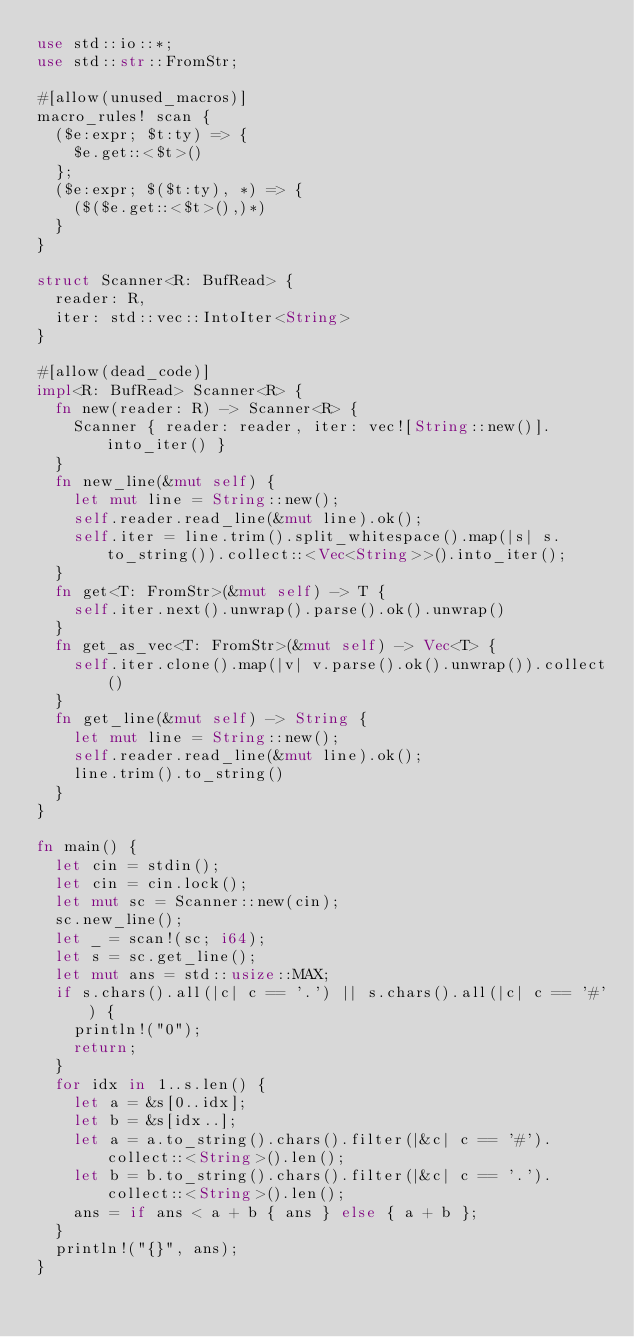Convert code to text. <code><loc_0><loc_0><loc_500><loc_500><_Rust_>use std::io::*;
use std::str::FromStr;

#[allow(unused_macros)]
macro_rules! scan {
  ($e:expr; $t:ty) => {
    $e.get::<$t>()
  };
  ($e:expr; $($t:ty), *) => {
    ($($e.get::<$t>(),)*)
  }
}

struct Scanner<R: BufRead> {
  reader: R,
  iter: std::vec::IntoIter<String>
}

#[allow(dead_code)]
impl<R: BufRead> Scanner<R> {
  fn new(reader: R) -> Scanner<R> {
    Scanner { reader: reader, iter: vec![String::new()].into_iter() }
  }
  fn new_line(&mut self) {
    let mut line = String::new();
    self.reader.read_line(&mut line).ok();
    self.iter = line.trim().split_whitespace().map(|s| s.to_string()).collect::<Vec<String>>().into_iter();
  }
  fn get<T: FromStr>(&mut self) -> T {
    self.iter.next().unwrap().parse().ok().unwrap()
  }
  fn get_as_vec<T: FromStr>(&mut self) -> Vec<T> {
    self.iter.clone().map(|v| v.parse().ok().unwrap()).collect()
  }
  fn get_line(&mut self) -> String {
    let mut line = String::new();
    self.reader.read_line(&mut line).ok();
    line.trim().to_string()
  }
}

fn main() {
  let cin = stdin();
  let cin = cin.lock();
  let mut sc = Scanner::new(cin);
  sc.new_line();
  let _ = scan!(sc; i64);
  let s = sc.get_line();
  let mut ans = std::usize::MAX;
  if s.chars().all(|c| c == '.') || s.chars().all(|c| c == '#') {
    println!("0");
    return;
  }
  for idx in 1..s.len() {
    let a = &s[0..idx];
    let b = &s[idx..];
    let a = a.to_string().chars().filter(|&c| c == '#').collect::<String>().len();
    let b = b.to_string().chars().filter(|&c| c == '.').collect::<String>().len();
    ans = if ans < a + b { ans } else { a + b };
  }
  println!("{}", ans);
}
</code> 